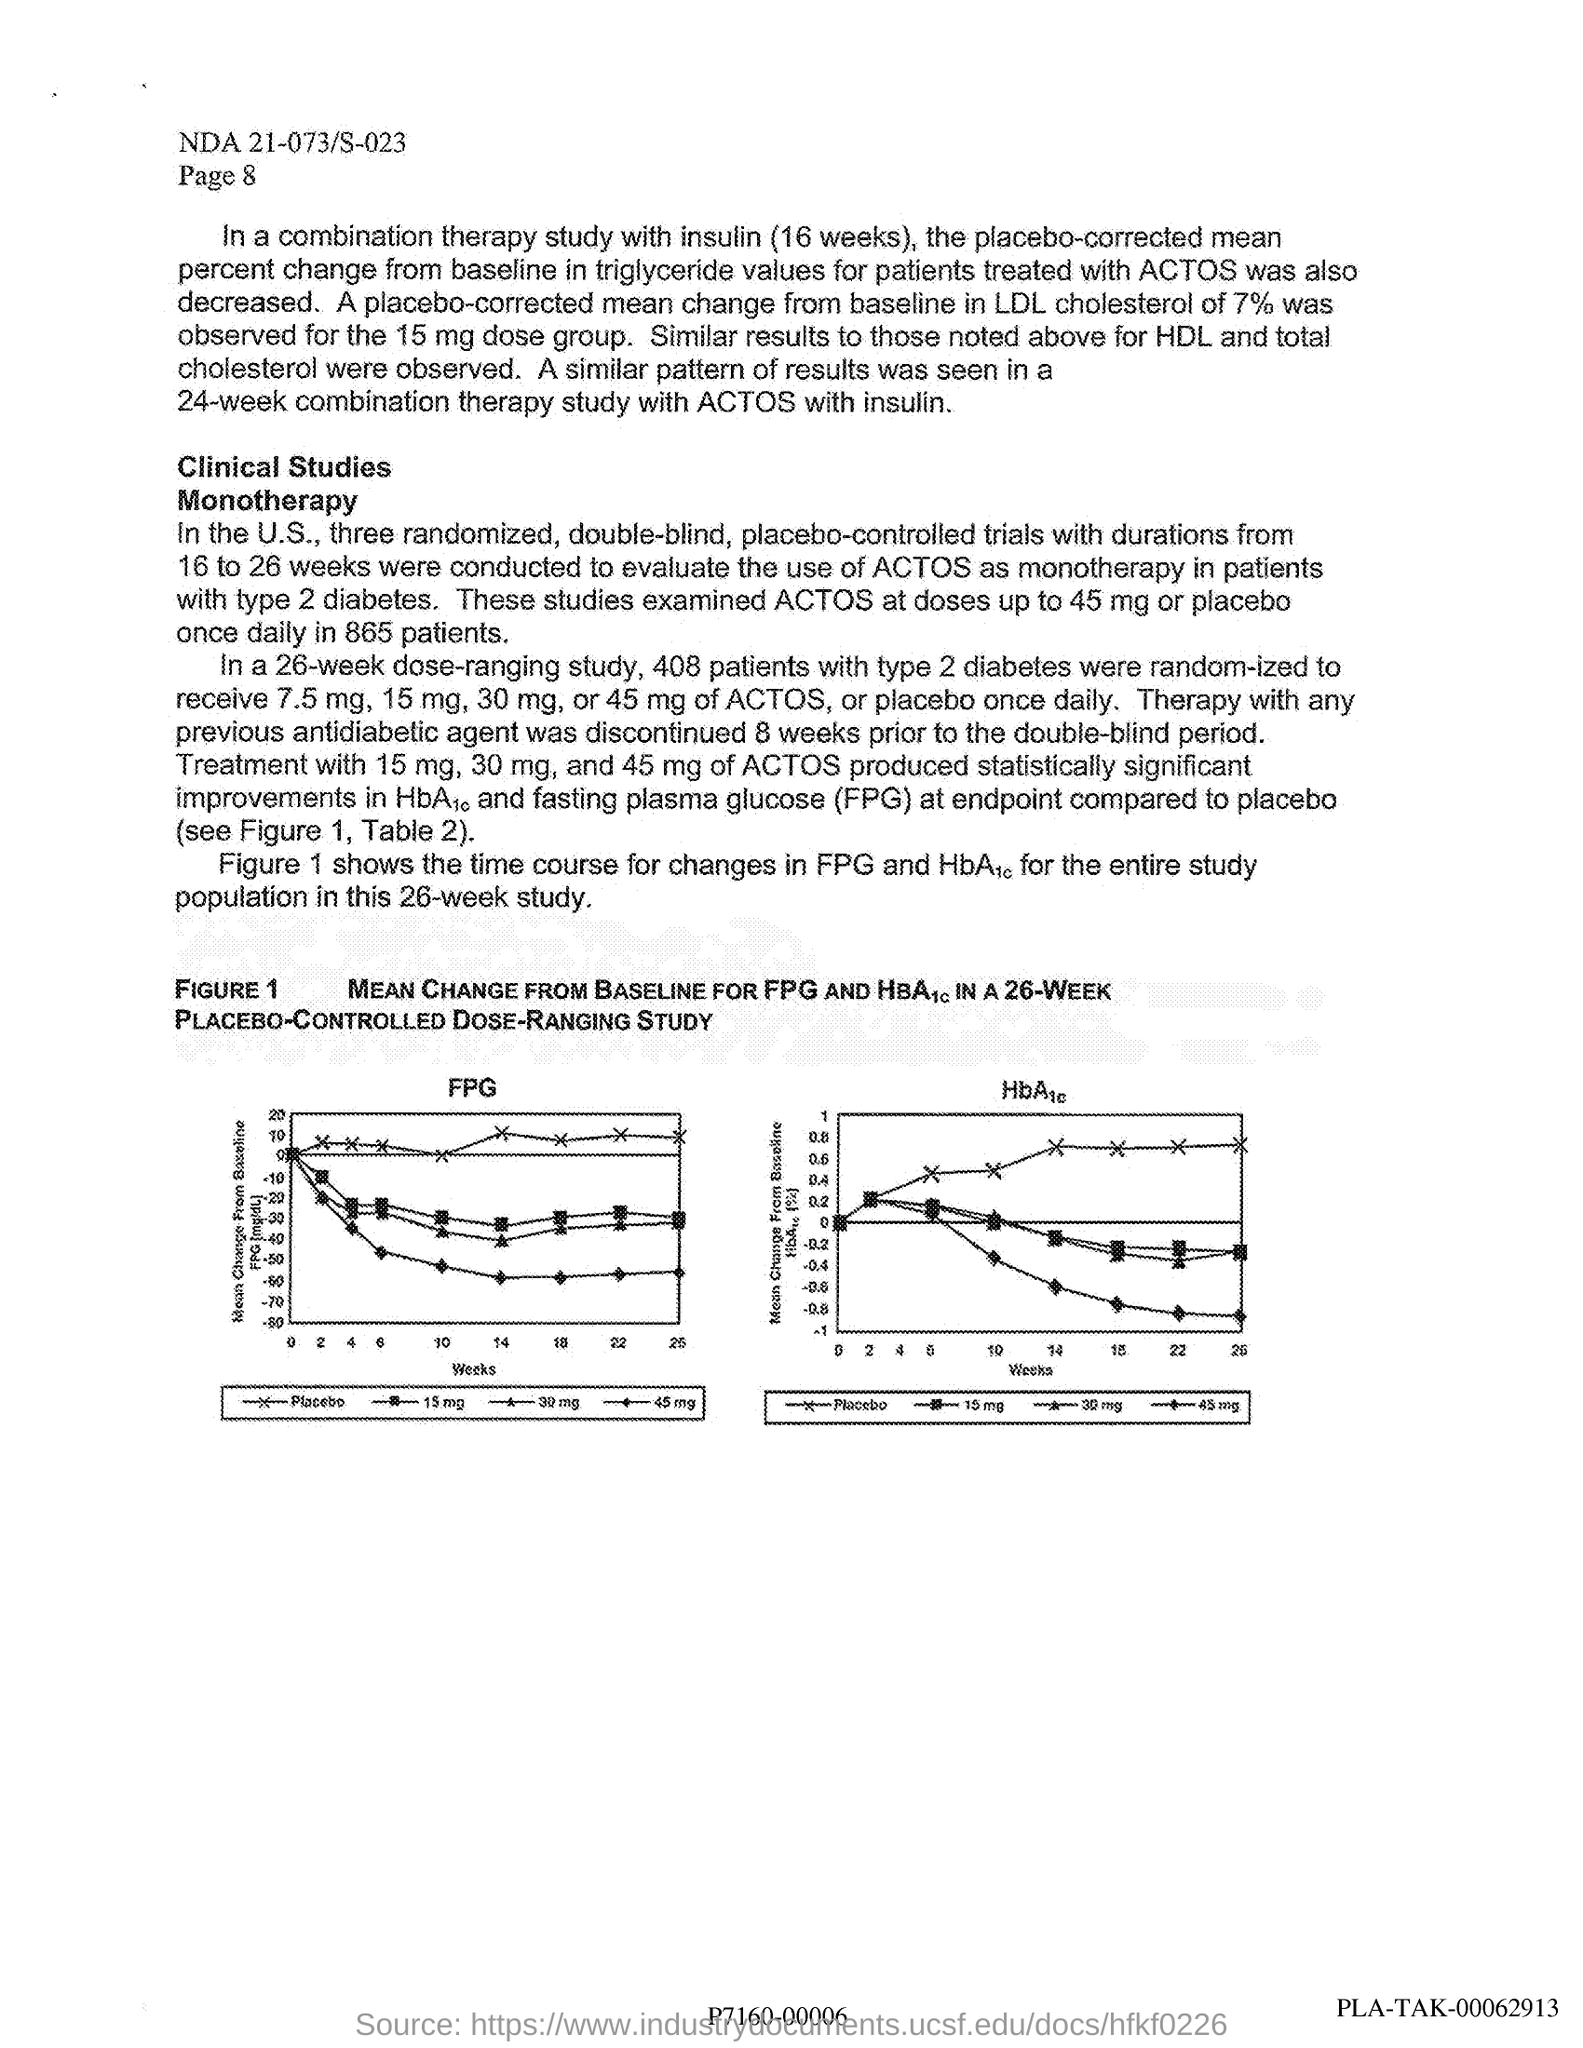List a handful of essential elements in this visual. The page number provided at the header of the document is 8. The document code at the header is "NDA 21-073/S-023. The value plotted on the X-axis in graphs is weeks. The study population for this research is all individuals who have been diagnosed with diabetes for at least 26 weeks. ACTOS is used as monotherapy in patients with type 2 diabetes. 